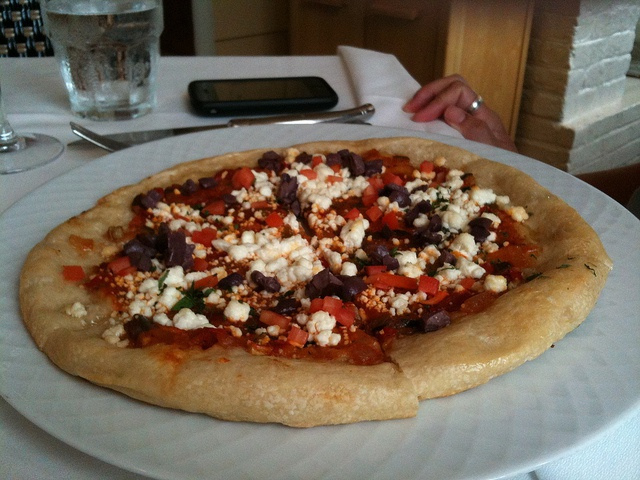Describe the objects in this image and their specific colors. I can see dining table in darkgray, black, maroon, and gray tones, pizza in black, maroon, and brown tones, cup in black and gray tones, cell phone in black, gray, and darkblue tones, and people in black, maroon, and brown tones in this image. 